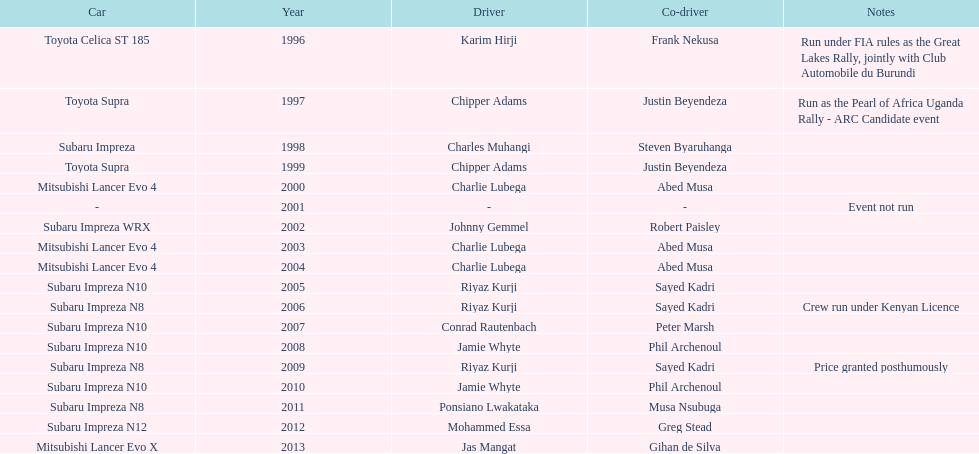How many drivers won at least twice? 4. 